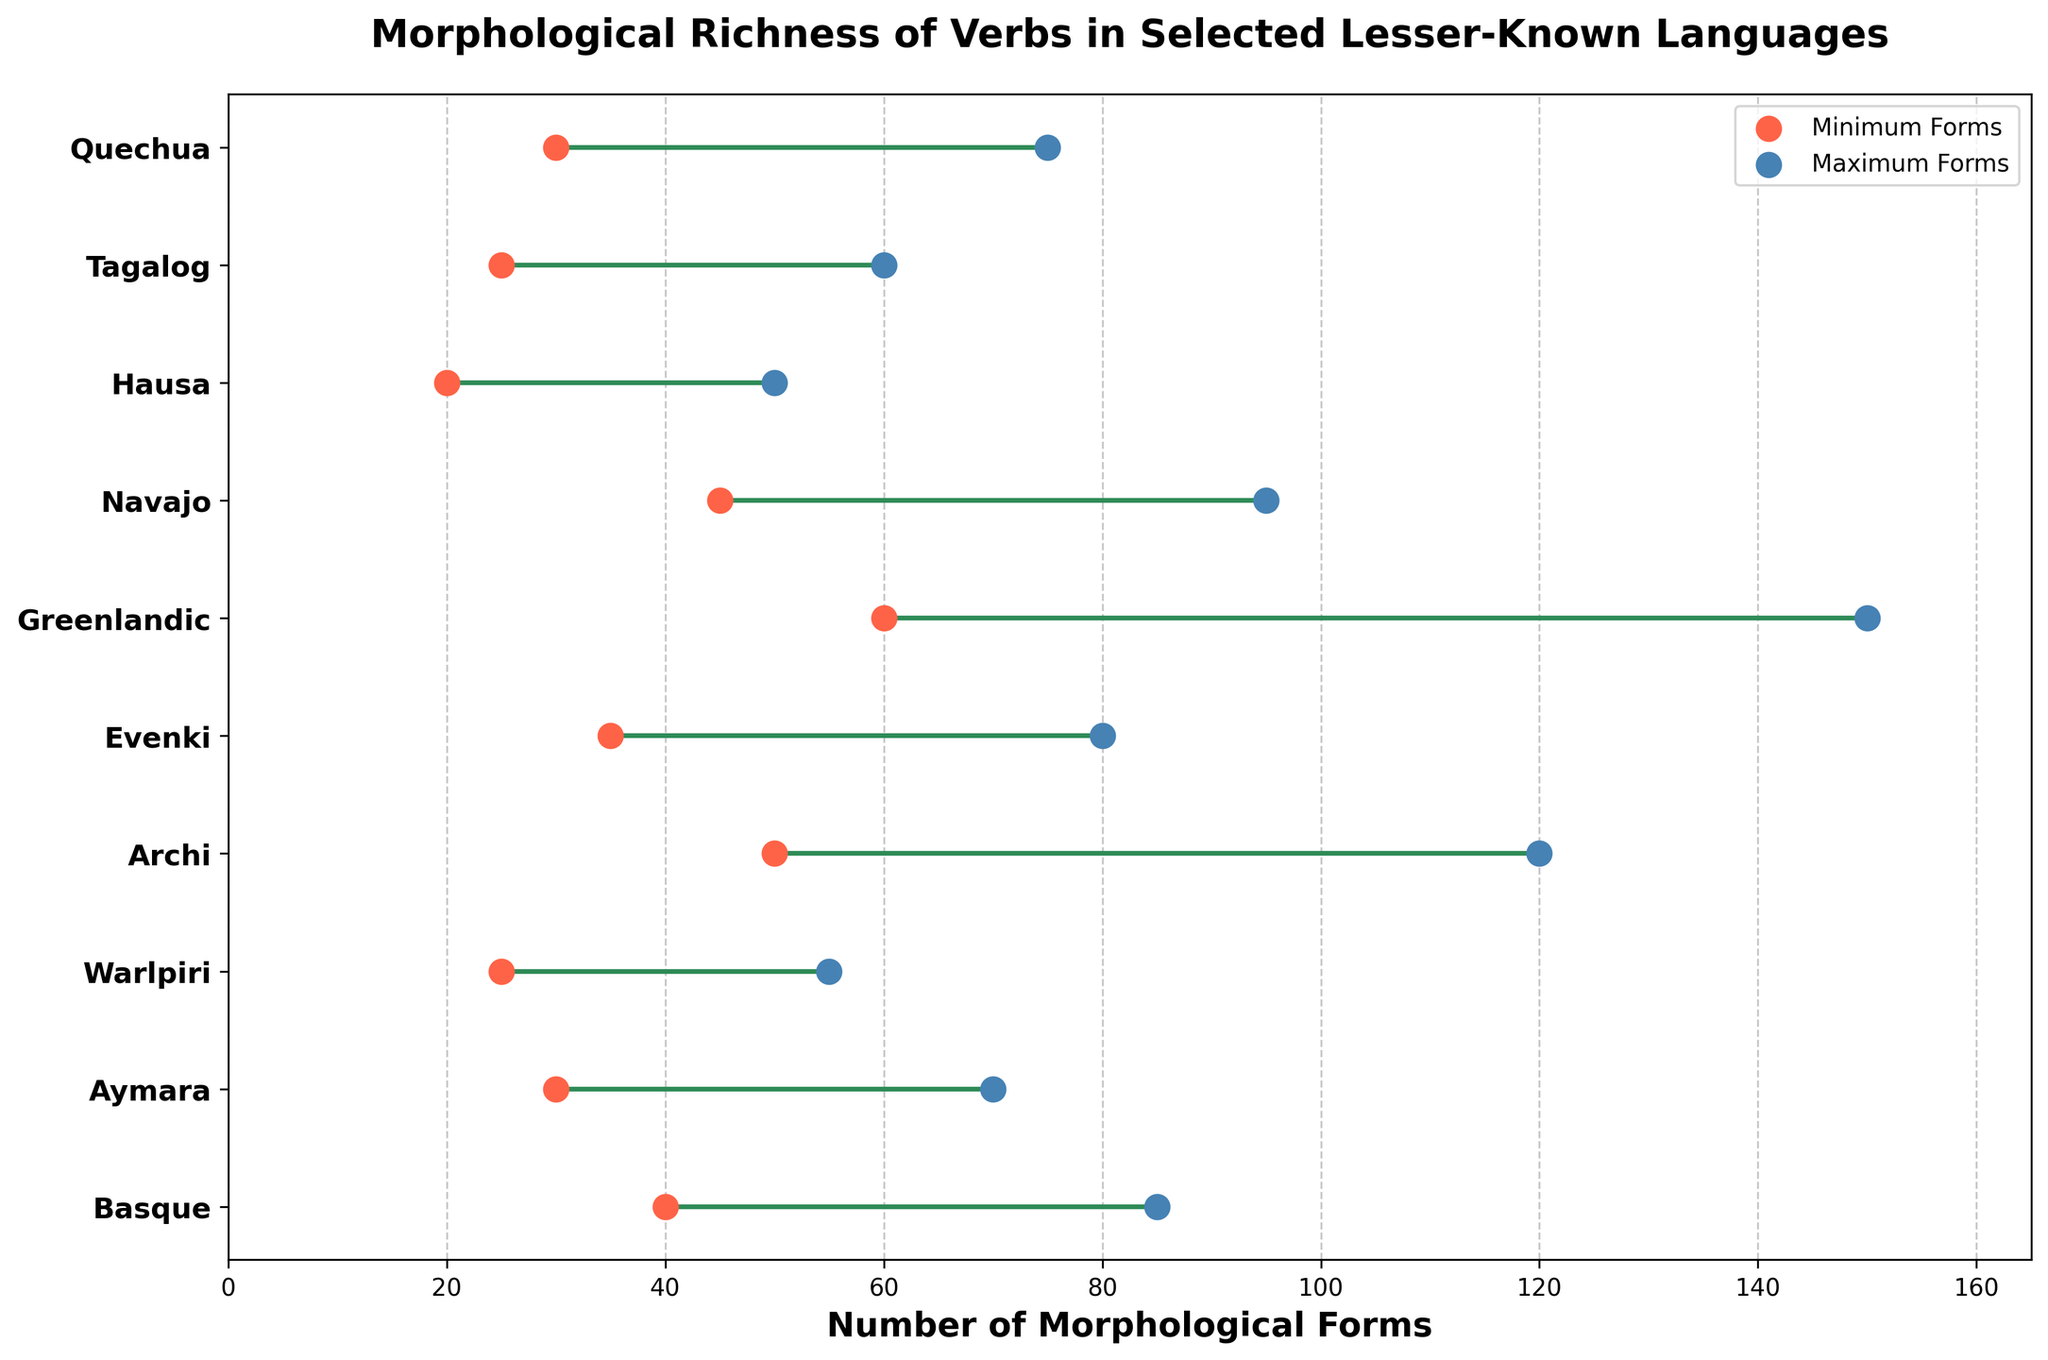What is the title of the plot? The title is located at the top of the plot, above the graph area. It is usually written in larger font size and bold to stand out.
Answer: Morphological Richness of Verbs in Selected Lesser-Known Languages How many languages are represented in the plot? Count the number of distinct y-axis labels, as each represents a different language.
Answer: 10 Which language has the highest number of maximum morphological forms? Look at the horizontal line with the highest end point (right side) and note the corresponding language on the y-axis.
Answer: Greenlandic What is the range of morphological forms for Archi? Identify the endpoints of Archi's horizontal line and calculate the difference between the maximum and minimum values.
Answer: 70 Which language has the narrowest range of morphological forms? Compare the lengths of the horizontal lines for each language and find the shortest one.
Answer: Hausa Which two languages have overlapping ranges of morphological forms? Look for languages that share a region on the x-axis where their horizontal lines overlap.
Answer: Basque and Navajo What is the average maximum number of morphological forms for all languages? Sum all maximum values for the 10 languages and divide by 10.
Answer: (85 + 70 + 55 + 120 + 80 + 150 + 95 + 50 + 60 + 75) / 10 = 84.0 How does the number of minimum morphological forms in Navajo compare to that in Tagalog? Compare the minimum values of Navajo and Tagalog by referring to the red dots.
Answer: 45 in Navajo is greater than 25 in Tagalog Are there any languages with at least 100 maximum morphological forms? Check the maximum values and see if any reach or exceed 100.
Answer: Yes (Greenlandic and Archi) Which language shows a total range of forms (min to max) closest to 50? Calculate the range for each language and find the one most approximately equal to 50.
Answer: Navaho (50) 